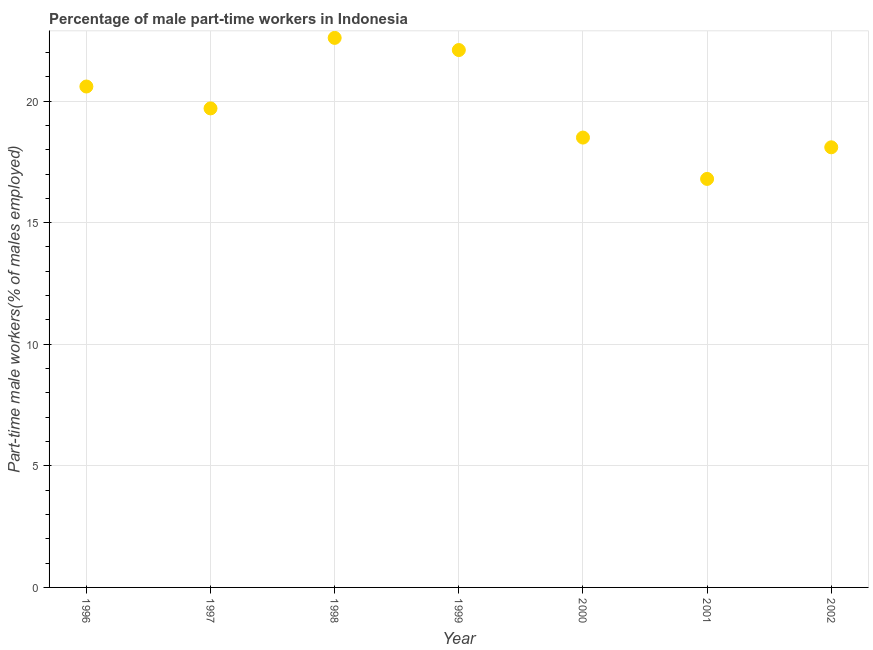What is the percentage of part-time male workers in 2000?
Your answer should be compact. 18.5. Across all years, what is the maximum percentage of part-time male workers?
Your answer should be compact. 22.6. Across all years, what is the minimum percentage of part-time male workers?
Make the answer very short. 16.8. What is the sum of the percentage of part-time male workers?
Offer a terse response. 138.4. What is the difference between the percentage of part-time male workers in 1998 and 2001?
Offer a terse response. 5.8. What is the average percentage of part-time male workers per year?
Your response must be concise. 19.77. What is the median percentage of part-time male workers?
Give a very brief answer. 19.7. In how many years, is the percentage of part-time male workers greater than 10 %?
Give a very brief answer. 7. Do a majority of the years between 1999 and 2000 (inclusive) have percentage of part-time male workers greater than 4 %?
Your response must be concise. Yes. What is the ratio of the percentage of part-time male workers in 1996 to that in 1998?
Keep it short and to the point. 0.91. Is the sum of the percentage of part-time male workers in 2000 and 2001 greater than the maximum percentage of part-time male workers across all years?
Your answer should be compact. Yes. What is the difference between the highest and the lowest percentage of part-time male workers?
Ensure brevity in your answer.  5.8. Does the graph contain any zero values?
Provide a succinct answer. No. What is the title of the graph?
Provide a short and direct response. Percentage of male part-time workers in Indonesia. What is the label or title of the Y-axis?
Offer a very short reply. Part-time male workers(% of males employed). What is the Part-time male workers(% of males employed) in 1996?
Offer a very short reply. 20.6. What is the Part-time male workers(% of males employed) in 1997?
Ensure brevity in your answer.  19.7. What is the Part-time male workers(% of males employed) in 1998?
Your response must be concise. 22.6. What is the Part-time male workers(% of males employed) in 1999?
Provide a short and direct response. 22.1. What is the Part-time male workers(% of males employed) in 2000?
Give a very brief answer. 18.5. What is the Part-time male workers(% of males employed) in 2001?
Your answer should be compact. 16.8. What is the Part-time male workers(% of males employed) in 2002?
Give a very brief answer. 18.1. What is the difference between the Part-time male workers(% of males employed) in 1996 and 1997?
Give a very brief answer. 0.9. What is the difference between the Part-time male workers(% of males employed) in 1996 and 1998?
Provide a succinct answer. -2. What is the difference between the Part-time male workers(% of males employed) in 1996 and 2001?
Your response must be concise. 3.8. What is the difference between the Part-time male workers(% of males employed) in 1996 and 2002?
Ensure brevity in your answer.  2.5. What is the difference between the Part-time male workers(% of males employed) in 1997 and 2000?
Your answer should be very brief. 1.2. What is the difference between the Part-time male workers(% of males employed) in 1997 and 2001?
Make the answer very short. 2.9. What is the difference between the Part-time male workers(% of males employed) in 1998 and 2000?
Make the answer very short. 4.1. What is the difference between the Part-time male workers(% of males employed) in 1998 and 2001?
Keep it short and to the point. 5.8. What is the difference between the Part-time male workers(% of males employed) in 1998 and 2002?
Provide a short and direct response. 4.5. What is the difference between the Part-time male workers(% of males employed) in 2000 and 2001?
Offer a very short reply. 1.7. What is the difference between the Part-time male workers(% of males employed) in 2000 and 2002?
Ensure brevity in your answer.  0.4. What is the ratio of the Part-time male workers(% of males employed) in 1996 to that in 1997?
Ensure brevity in your answer.  1.05. What is the ratio of the Part-time male workers(% of males employed) in 1996 to that in 1998?
Keep it short and to the point. 0.91. What is the ratio of the Part-time male workers(% of males employed) in 1996 to that in 1999?
Give a very brief answer. 0.93. What is the ratio of the Part-time male workers(% of males employed) in 1996 to that in 2000?
Your response must be concise. 1.11. What is the ratio of the Part-time male workers(% of males employed) in 1996 to that in 2001?
Your response must be concise. 1.23. What is the ratio of the Part-time male workers(% of males employed) in 1996 to that in 2002?
Give a very brief answer. 1.14. What is the ratio of the Part-time male workers(% of males employed) in 1997 to that in 1998?
Offer a terse response. 0.87. What is the ratio of the Part-time male workers(% of males employed) in 1997 to that in 1999?
Give a very brief answer. 0.89. What is the ratio of the Part-time male workers(% of males employed) in 1997 to that in 2000?
Your answer should be compact. 1.06. What is the ratio of the Part-time male workers(% of males employed) in 1997 to that in 2001?
Your answer should be very brief. 1.17. What is the ratio of the Part-time male workers(% of males employed) in 1997 to that in 2002?
Make the answer very short. 1.09. What is the ratio of the Part-time male workers(% of males employed) in 1998 to that in 2000?
Ensure brevity in your answer.  1.22. What is the ratio of the Part-time male workers(% of males employed) in 1998 to that in 2001?
Your answer should be very brief. 1.34. What is the ratio of the Part-time male workers(% of males employed) in 1998 to that in 2002?
Give a very brief answer. 1.25. What is the ratio of the Part-time male workers(% of males employed) in 1999 to that in 2000?
Your answer should be very brief. 1.2. What is the ratio of the Part-time male workers(% of males employed) in 1999 to that in 2001?
Keep it short and to the point. 1.31. What is the ratio of the Part-time male workers(% of males employed) in 1999 to that in 2002?
Your response must be concise. 1.22. What is the ratio of the Part-time male workers(% of males employed) in 2000 to that in 2001?
Provide a short and direct response. 1.1. What is the ratio of the Part-time male workers(% of males employed) in 2001 to that in 2002?
Your answer should be very brief. 0.93. 